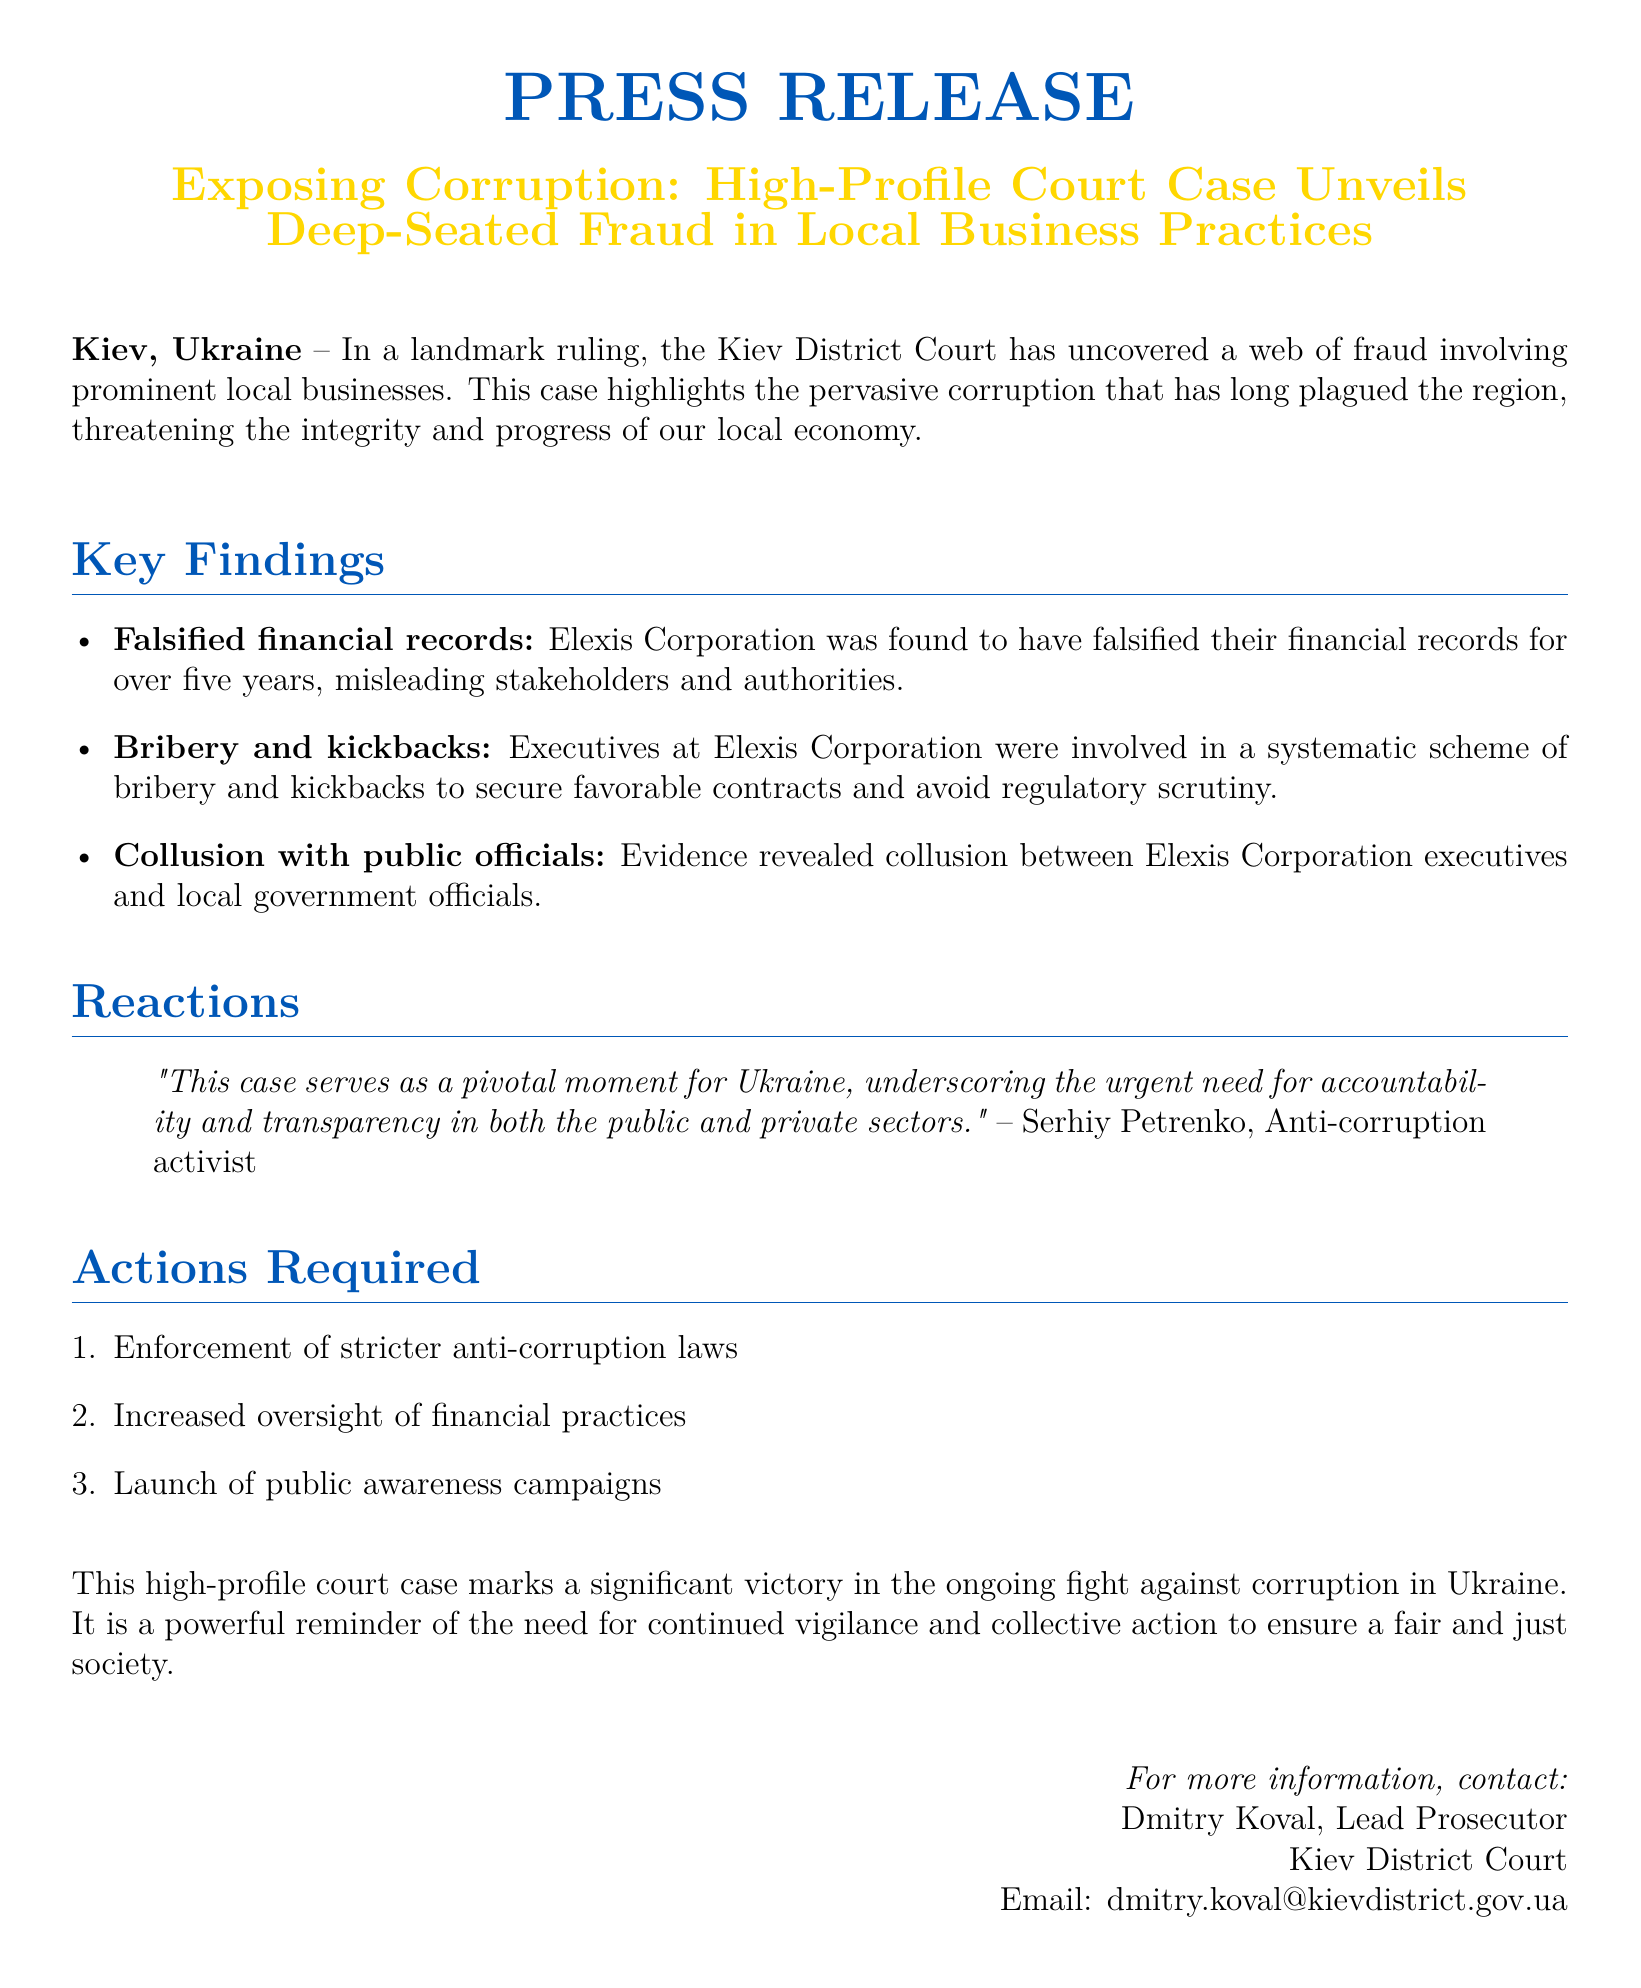What was the main finding of the Kiev District Court? The main finding was the uncovering of a web of fraud involving prominent local businesses.
Answer: A web of fraud Who was involved in the bribery scheme? The executives at Elexis Corporation were involved in a systematic scheme of bribery and kickbacks.
Answer: Executives at Elexis Corporation How long did Elexis Corporation falsify their financial records? Elexis Corporation falsified their financial records for over five years.
Answer: Over five years What urgent need does this case underscore? The case underscores the urgent need for accountability and transparency.
Answer: Accountability and transparency Who provided a quote about the significance of the case? The quote was provided by Serhiy Petrenko, an anti-corruption activist.
Answer: Serhiy Petrenko What actions are required following the ruling? Three actions are required: enforcement of stricter anti-corruption laws, increased oversight of financial practices, and launch of public awareness campaigns.
Answer: Three actions What is the primary focus of the press release? The primary focus is on exposing corruption and fraud in local business practices.
Answer: Exposing corruption What is the location of the Kiev District Court? The location of the court is Kiev, Ukraine.
Answer: Kiev, Ukraine 